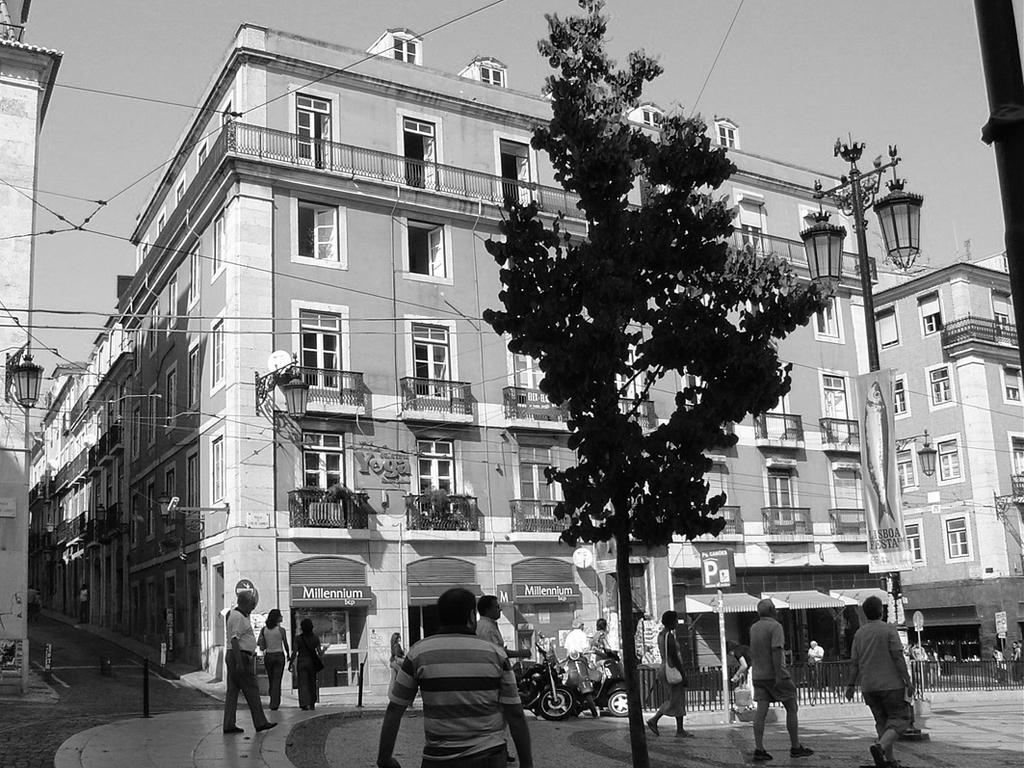How would you summarize this image in a sentence or two? This is a black and white picture. There are some persons and bikes. Here we can see poles, boards, fence, lights, hoardings, boards, wires, and buildings. This is road. There is a tree and there are plants. In the background there is sky. 